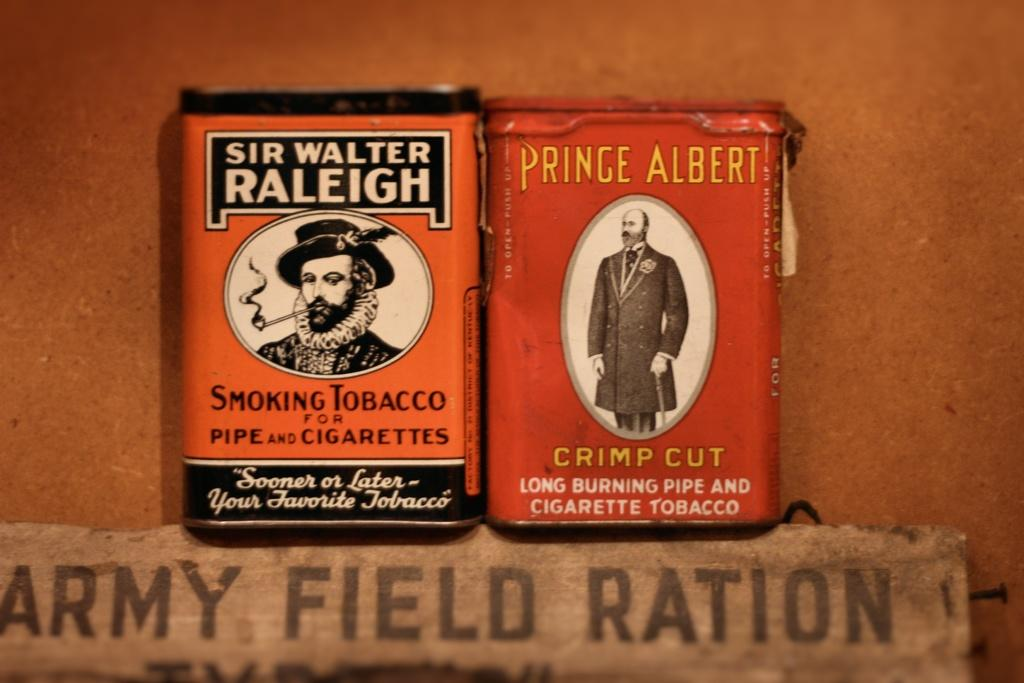<image>
Describe the image concisely. Two containers of Smoking tobacco with differing brands on them one being sir walter raleigh and prince albert on them. 